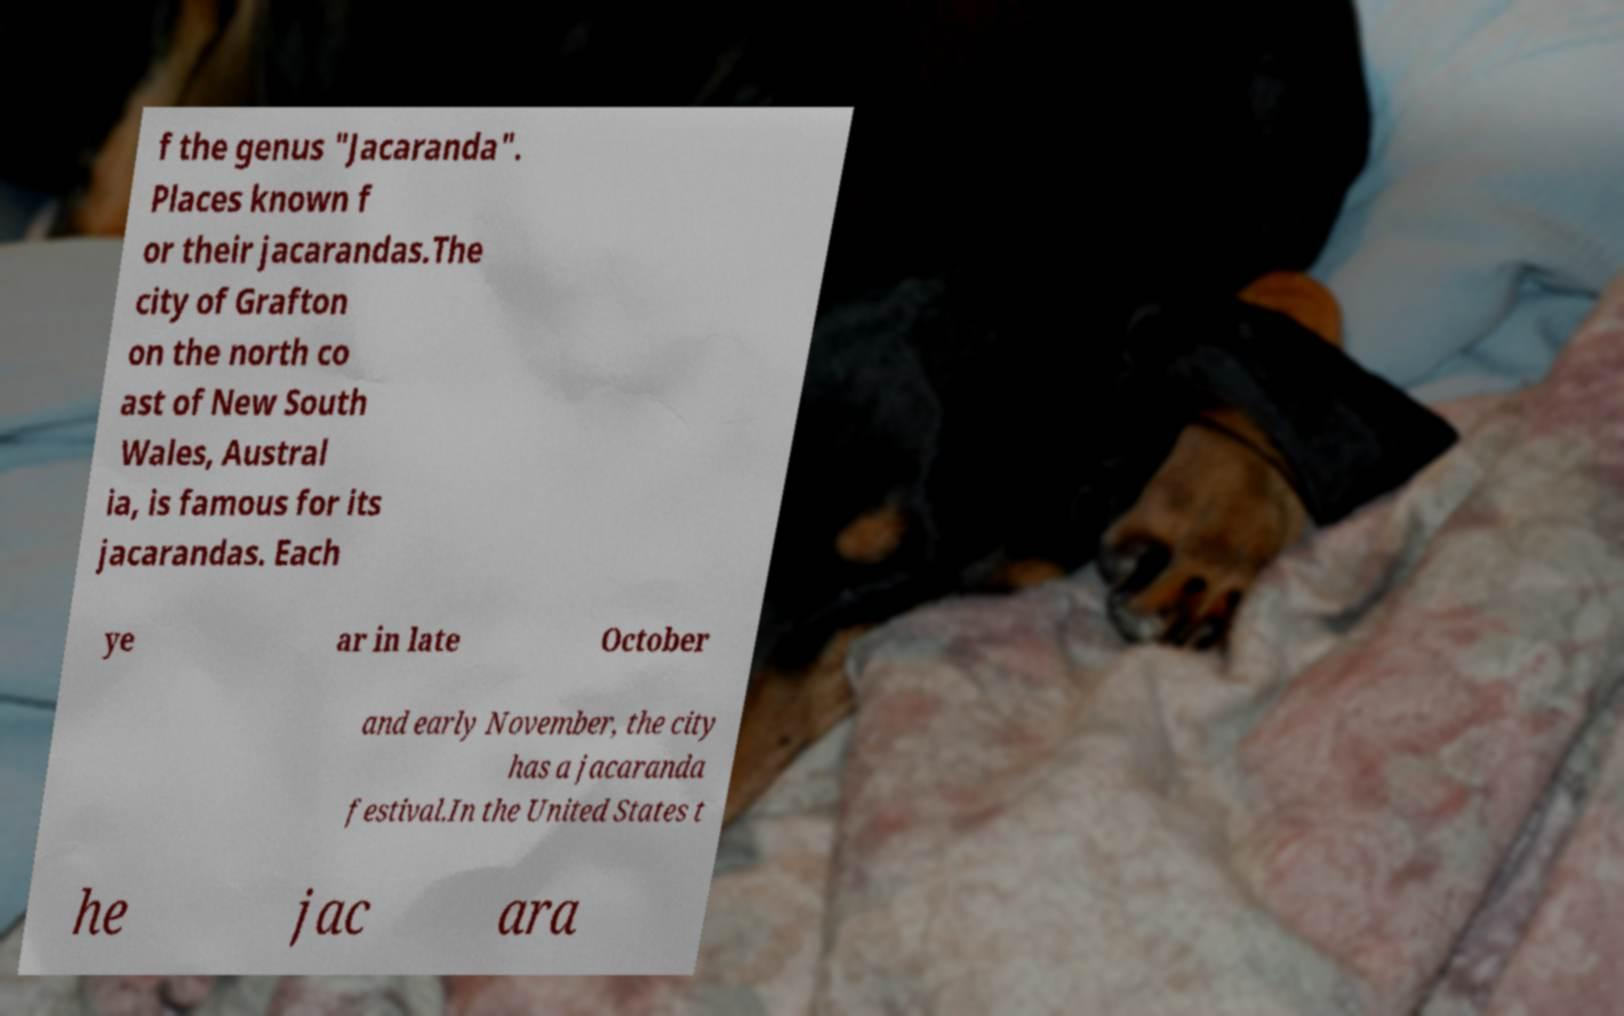What messages or text are displayed in this image? I need them in a readable, typed format. f the genus "Jacaranda". Places known f or their jacarandas.The city of Grafton on the north co ast of New South Wales, Austral ia, is famous for its jacarandas. Each ye ar in late October and early November, the city has a jacaranda festival.In the United States t he jac ara 